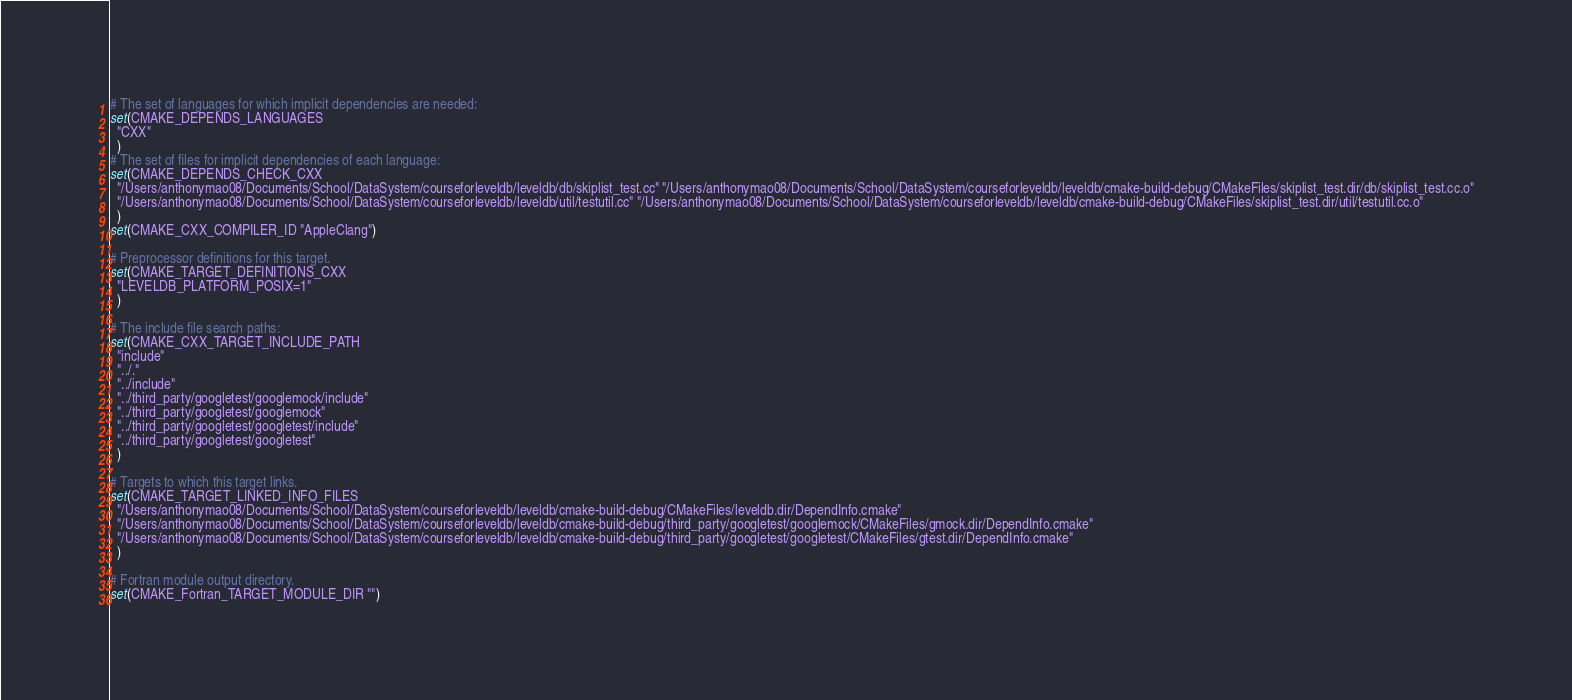<code> <loc_0><loc_0><loc_500><loc_500><_CMake_># The set of languages for which implicit dependencies are needed:
set(CMAKE_DEPENDS_LANGUAGES
  "CXX"
  )
# The set of files for implicit dependencies of each language:
set(CMAKE_DEPENDS_CHECK_CXX
  "/Users/anthonymao08/Documents/School/DataSystem/courseforleveldb/leveldb/db/skiplist_test.cc" "/Users/anthonymao08/Documents/School/DataSystem/courseforleveldb/leveldb/cmake-build-debug/CMakeFiles/skiplist_test.dir/db/skiplist_test.cc.o"
  "/Users/anthonymao08/Documents/School/DataSystem/courseforleveldb/leveldb/util/testutil.cc" "/Users/anthonymao08/Documents/School/DataSystem/courseforleveldb/leveldb/cmake-build-debug/CMakeFiles/skiplist_test.dir/util/testutil.cc.o"
  )
set(CMAKE_CXX_COMPILER_ID "AppleClang")

# Preprocessor definitions for this target.
set(CMAKE_TARGET_DEFINITIONS_CXX
  "LEVELDB_PLATFORM_POSIX=1"
  )

# The include file search paths:
set(CMAKE_CXX_TARGET_INCLUDE_PATH
  "include"
  "../."
  "../include"
  "../third_party/googletest/googlemock/include"
  "../third_party/googletest/googlemock"
  "../third_party/googletest/googletest/include"
  "../third_party/googletest/googletest"
  )

# Targets to which this target links.
set(CMAKE_TARGET_LINKED_INFO_FILES
  "/Users/anthonymao08/Documents/School/DataSystem/courseforleveldb/leveldb/cmake-build-debug/CMakeFiles/leveldb.dir/DependInfo.cmake"
  "/Users/anthonymao08/Documents/School/DataSystem/courseforleveldb/leveldb/cmake-build-debug/third_party/googletest/googlemock/CMakeFiles/gmock.dir/DependInfo.cmake"
  "/Users/anthonymao08/Documents/School/DataSystem/courseforleveldb/leveldb/cmake-build-debug/third_party/googletest/googletest/CMakeFiles/gtest.dir/DependInfo.cmake"
  )

# Fortran module output directory.
set(CMAKE_Fortran_TARGET_MODULE_DIR "")
</code> 